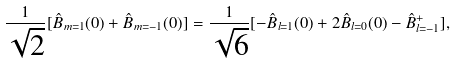Convert formula to latex. <formula><loc_0><loc_0><loc_500><loc_500>\frac { 1 } { \sqrt { 2 } } [ \hat { B } _ { m = 1 } ( 0 ) + \hat { B } _ { m = - 1 } ( 0 ) ] = \frac { 1 } { \sqrt { 6 } } [ - \hat { B } _ { l = 1 } ( 0 ) + 2 \hat { B } _ { l = 0 } ( 0 ) - \hat { B } _ { l = - 1 } ^ { + } ] ,</formula> 